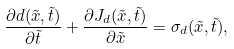<formula> <loc_0><loc_0><loc_500><loc_500>\frac { \partial d ( \tilde { x } , \tilde { t } ) } { \partial \tilde { t } } + \frac { \partial J _ { d } ( \tilde { x } , \tilde { t } ) } { \partial \tilde { x } } = \sigma _ { d } ( \tilde { x } , \tilde { t } ) ,</formula> 